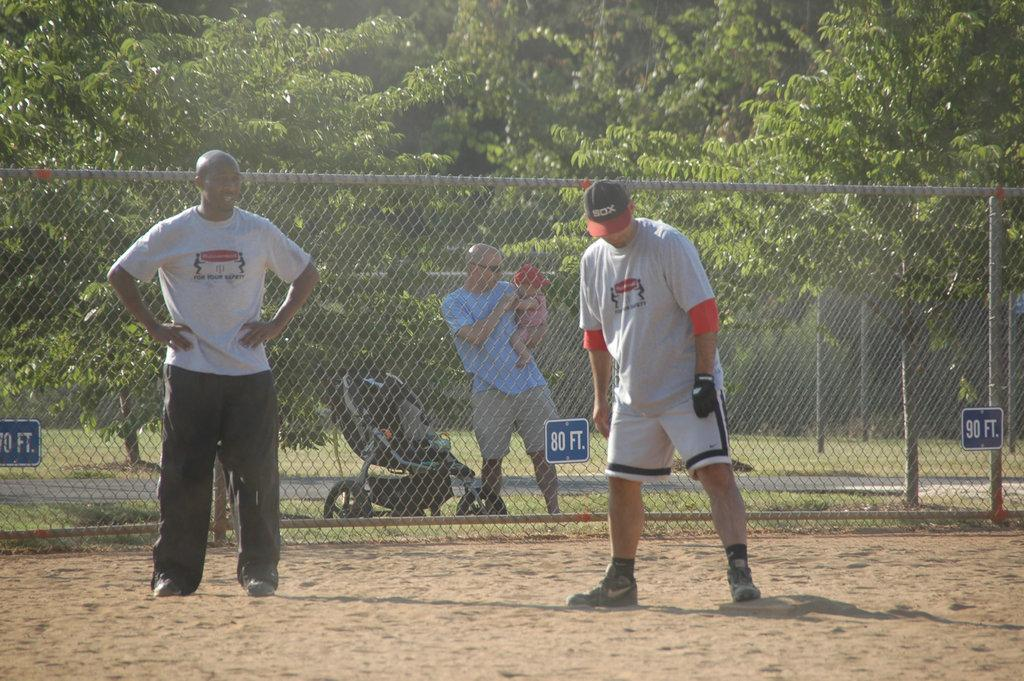<image>
Share a concise interpretation of the image provided. A sign on a fence is marked 80 ft. 